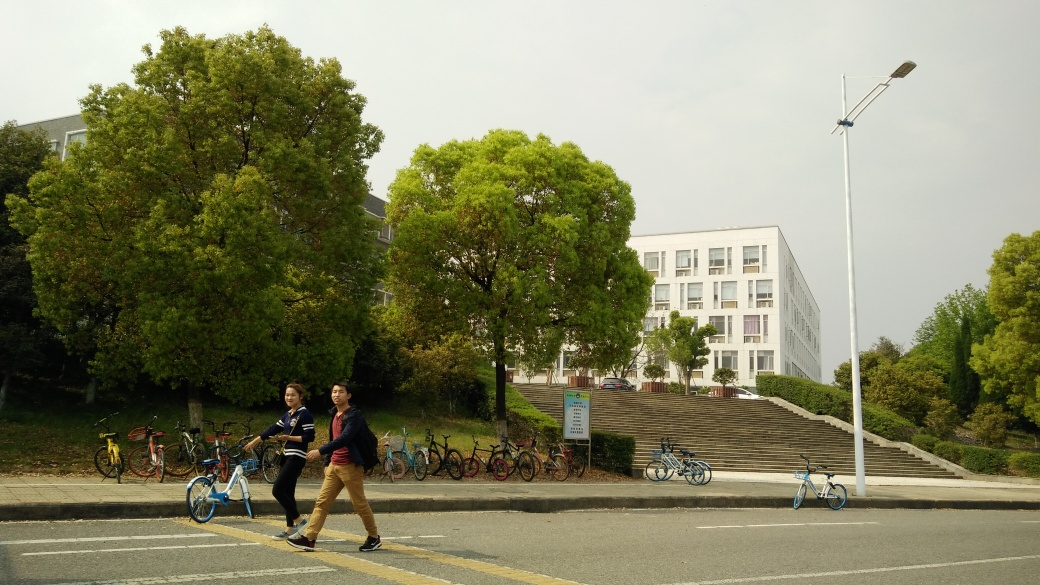Does the image have any motion blur? The image appears to have no motion blur; the subjects and the environment are both crisp and clear, indicating a still moment captured with a fast shutter speed or ample lighting. 